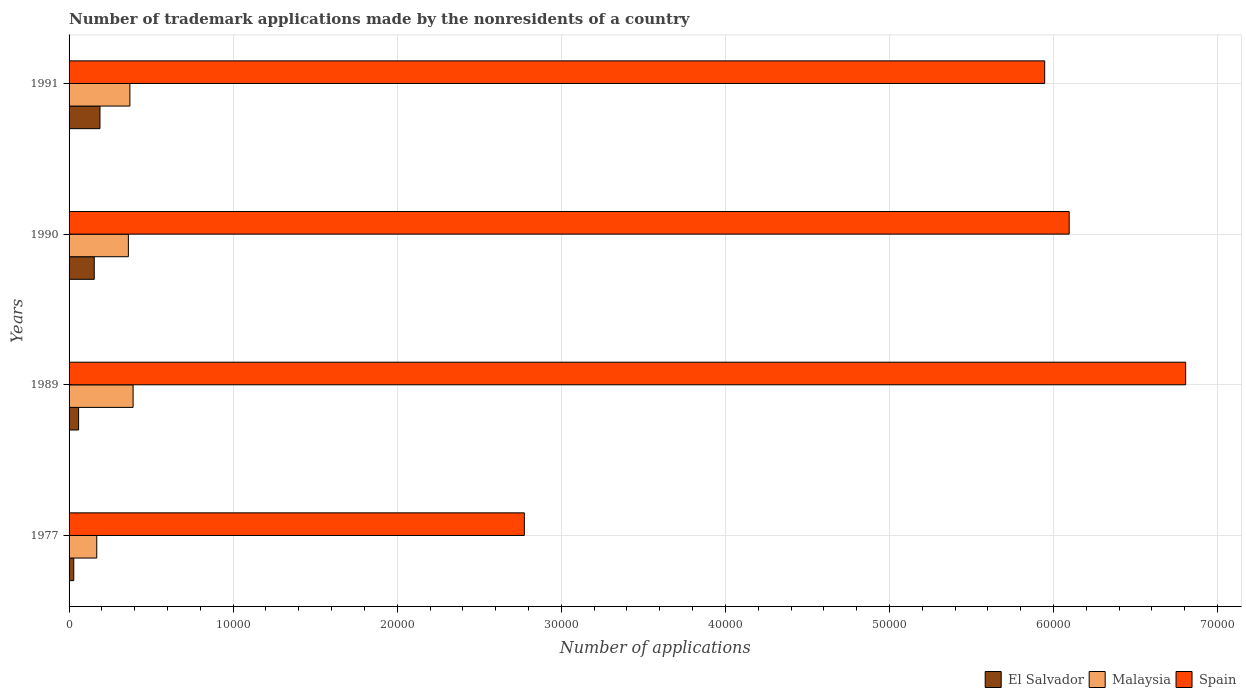Are the number of bars on each tick of the Y-axis equal?
Offer a terse response. Yes. How many bars are there on the 1st tick from the top?
Offer a very short reply. 3. How many bars are there on the 1st tick from the bottom?
Your response must be concise. 3. In how many cases, is the number of bars for a given year not equal to the number of legend labels?
Offer a very short reply. 0. What is the number of trademark applications made by the nonresidents in El Salvador in 1977?
Give a very brief answer. 287. Across all years, what is the maximum number of trademark applications made by the nonresidents in El Salvador?
Your answer should be compact. 1883. Across all years, what is the minimum number of trademark applications made by the nonresidents in Spain?
Keep it short and to the point. 2.77e+04. In which year was the number of trademark applications made by the nonresidents in Spain maximum?
Offer a very short reply. 1989. What is the total number of trademark applications made by the nonresidents in El Salvador in the graph?
Offer a very short reply. 4286. What is the difference between the number of trademark applications made by the nonresidents in Malaysia in 1977 and that in 1989?
Give a very brief answer. -2215. What is the difference between the number of trademark applications made by the nonresidents in Malaysia in 1990 and the number of trademark applications made by the nonresidents in El Salvador in 1991?
Provide a short and direct response. 1731. What is the average number of trademark applications made by the nonresidents in El Salvador per year?
Your response must be concise. 1071.5. In the year 1990, what is the difference between the number of trademark applications made by the nonresidents in Spain and number of trademark applications made by the nonresidents in Malaysia?
Ensure brevity in your answer.  5.73e+04. In how many years, is the number of trademark applications made by the nonresidents in El Salvador greater than 46000 ?
Your answer should be very brief. 0. What is the ratio of the number of trademark applications made by the nonresidents in Malaysia in 1977 to that in 1991?
Provide a succinct answer. 0.46. Is the number of trademark applications made by the nonresidents in Malaysia in 1989 less than that in 1990?
Keep it short and to the point. No. Is the difference between the number of trademark applications made by the nonresidents in Spain in 1977 and 1989 greater than the difference between the number of trademark applications made by the nonresidents in Malaysia in 1977 and 1989?
Your response must be concise. No. What is the difference between the highest and the second highest number of trademark applications made by the nonresidents in Spain?
Your answer should be compact. 7100. What is the difference between the highest and the lowest number of trademark applications made by the nonresidents in Malaysia?
Keep it short and to the point. 2215. In how many years, is the number of trademark applications made by the nonresidents in El Salvador greater than the average number of trademark applications made by the nonresidents in El Salvador taken over all years?
Provide a succinct answer. 2. Is the sum of the number of trademark applications made by the nonresidents in El Salvador in 1990 and 1991 greater than the maximum number of trademark applications made by the nonresidents in Spain across all years?
Provide a succinct answer. No. What does the 1st bar from the bottom in 1990 represents?
Keep it short and to the point. El Salvador. How many bars are there?
Provide a succinct answer. 12. How many years are there in the graph?
Provide a succinct answer. 4. What is the difference between two consecutive major ticks on the X-axis?
Offer a terse response. 10000. Are the values on the major ticks of X-axis written in scientific E-notation?
Keep it short and to the point. No. Does the graph contain any zero values?
Make the answer very short. No. Does the graph contain grids?
Make the answer very short. Yes. Where does the legend appear in the graph?
Offer a very short reply. Bottom right. What is the title of the graph?
Provide a succinct answer. Number of trademark applications made by the nonresidents of a country. Does "Kosovo" appear as one of the legend labels in the graph?
Your answer should be very brief. No. What is the label or title of the X-axis?
Your answer should be compact. Number of applications. What is the Number of applications in El Salvador in 1977?
Offer a terse response. 287. What is the Number of applications in Malaysia in 1977?
Offer a terse response. 1687. What is the Number of applications in Spain in 1977?
Your answer should be compact. 2.77e+04. What is the Number of applications in El Salvador in 1989?
Offer a terse response. 581. What is the Number of applications of Malaysia in 1989?
Ensure brevity in your answer.  3902. What is the Number of applications of Spain in 1989?
Your answer should be compact. 6.81e+04. What is the Number of applications of El Salvador in 1990?
Give a very brief answer. 1535. What is the Number of applications of Malaysia in 1990?
Give a very brief answer. 3614. What is the Number of applications in Spain in 1990?
Your answer should be very brief. 6.10e+04. What is the Number of applications in El Salvador in 1991?
Ensure brevity in your answer.  1883. What is the Number of applications in Malaysia in 1991?
Your answer should be very brief. 3707. What is the Number of applications of Spain in 1991?
Provide a succinct answer. 5.95e+04. Across all years, what is the maximum Number of applications in El Salvador?
Offer a very short reply. 1883. Across all years, what is the maximum Number of applications of Malaysia?
Your answer should be compact. 3902. Across all years, what is the maximum Number of applications in Spain?
Offer a very short reply. 6.81e+04. Across all years, what is the minimum Number of applications of El Salvador?
Ensure brevity in your answer.  287. Across all years, what is the minimum Number of applications of Malaysia?
Your answer should be compact. 1687. Across all years, what is the minimum Number of applications of Spain?
Give a very brief answer. 2.77e+04. What is the total Number of applications in El Salvador in the graph?
Offer a terse response. 4286. What is the total Number of applications of Malaysia in the graph?
Provide a succinct answer. 1.29e+04. What is the total Number of applications of Spain in the graph?
Give a very brief answer. 2.16e+05. What is the difference between the Number of applications of El Salvador in 1977 and that in 1989?
Your response must be concise. -294. What is the difference between the Number of applications in Malaysia in 1977 and that in 1989?
Your answer should be very brief. -2215. What is the difference between the Number of applications of Spain in 1977 and that in 1989?
Make the answer very short. -4.03e+04. What is the difference between the Number of applications in El Salvador in 1977 and that in 1990?
Keep it short and to the point. -1248. What is the difference between the Number of applications in Malaysia in 1977 and that in 1990?
Provide a succinct answer. -1927. What is the difference between the Number of applications in Spain in 1977 and that in 1990?
Your answer should be very brief. -3.32e+04. What is the difference between the Number of applications of El Salvador in 1977 and that in 1991?
Provide a short and direct response. -1596. What is the difference between the Number of applications in Malaysia in 1977 and that in 1991?
Ensure brevity in your answer.  -2020. What is the difference between the Number of applications of Spain in 1977 and that in 1991?
Offer a very short reply. -3.17e+04. What is the difference between the Number of applications in El Salvador in 1989 and that in 1990?
Make the answer very short. -954. What is the difference between the Number of applications of Malaysia in 1989 and that in 1990?
Provide a succinct answer. 288. What is the difference between the Number of applications in Spain in 1989 and that in 1990?
Keep it short and to the point. 7100. What is the difference between the Number of applications of El Salvador in 1989 and that in 1991?
Offer a terse response. -1302. What is the difference between the Number of applications in Malaysia in 1989 and that in 1991?
Provide a succinct answer. 195. What is the difference between the Number of applications in Spain in 1989 and that in 1991?
Keep it short and to the point. 8592. What is the difference between the Number of applications of El Salvador in 1990 and that in 1991?
Offer a terse response. -348. What is the difference between the Number of applications in Malaysia in 1990 and that in 1991?
Ensure brevity in your answer.  -93. What is the difference between the Number of applications in Spain in 1990 and that in 1991?
Make the answer very short. 1492. What is the difference between the Number of applications in El Salvador in 1977 and the Number of applications in Malaysia in 1989?
Offer a terse response. -3615. What is the difference between the Number of applications of El Salvador in 1977 and the Number of applications of Spain in 1989?
Offer a very short reply. -6.78e+04. What is the difference between the Number of applications in Malaysia in 1977 and the Number of applications in Spain in 1989?
Provide a short and direct response. -6.64e+04. What is the difference between the Number of applications in El Salvador in 1977 and the Number of applications in Malaysia in 1990?
Offer a terse response. -3327. What is the difference between the Number of applications of El Salvador in 1977 and the Number of applications of Spain in 1990?
Make the answer very short. -6.07e+04. What is the difference between the Number of applications of Malaysia in 1977 and the Number of applications of Spain in 1990?
Provide a short and direct response. -5.93e+04. What is the difference between the Number of applications of El Salvador in 1977 and the Number of applications of Malaysia in 1991?
Offer a very short reply. -3420. What is the difference between the Number of applications of El Salvador in 1977 and the Number of applications of Spain in 1991?
Your answer should be compact. -5.92e+04. What is the difference between the Number of applications of Malaysia in 1977 and the Number of applications of Spain in 1991?
Make the answer very short. -5.78e+04. What is the difference between the Number of applications of El Salvador in 1989 and the Number of applications of Malaysia in 1990?
Provide a short and direct response. -3033. What is the difference between the Number of applications in El Salvador in 1989 and the Number of applications in Spain in 1990?
Provide a short and direct response. -6.04e+04. What is the difference between the Number of applications of Malaysia in 1989 and the Number of applications of Spain in 1990?
Keep it short and to the point. -5.71e+04. What is the difference between the Number of applications in El Salvador in 1989 and the Number of applications in Malaysia in 1991?
Your answer should be compact. -3126. What is the difference between the Number of applications of El Salvador in 1989 and the Number of applications of Spain in 1991?
Your answer should be compact. -5.89e+04. What is the difference between the Number of applications of Malaysia in 1989 and the Number of applications of Spain in 1991?
Your answer should be very brief. -5.56e+04. What is the difference between the Number of applications of El Salvador in 1990 and the Number of applications of Malaysia in 1991?
Make the answer very short. -2172. What is the difference between the Number of applications in El Salvador in 1990 and the Number of applications in Spain in 1991?
Your answer should be very brief. -5.79e+04. What is the difference between the Number of applications in Malaysia in 1990 and the Number of applications in Spain in 1991?
Your answer should be very brief. -5.58e+04. What is the average Number of applications in El Salvador per year?
Ensure brevity in your answer.  1071.5. What is the average Number of applications in Malaysia per year?
Ensure brevity in your answer.  3227.5. What is the average Number of applications of Spain per year?
Your response must be concise. 5.41e+04. In the year 1977, what is the difference between the Number of applications in El Salvador and Number of applications in Malaysia?
Offer a terse response. -1400. In the year 1977, what is the difference between the Number of applications in El Salvador and Number of applications in Spain?
Make the answer very short. -2.75e+04. In the year 1977, what is the difference between the Number of applications of Malaysia and Number of applications of Spain?
Your answer should be compact. -2.61e+04. In the year 1989, what is the difference between the Number of applications of El Salvador and Number of applications of Malaysia?
Make the answer very short. -3321. In the year 1989, what is the difference between the Number of applications of El Salvador and Number of applications of Spain?
Make the answer very short. -6.75e+04. In the year 1989, what is the difference between the Number of applications in Malaysia and Number of applications in Spain?
Offer a terse response. -6.42e+04. In the year 1990, what is the difference between the Number of applications in El Salvador and Number of applications in Malaysia?
Give a very brief answer. -2079. In the year 1990, what is the difference between the Number of applications in El Salvador and Number of applications in Spain?
Your answer should be very brief. -5.94e+04. In the year 1990, what is the difference between the Number of applications of Malaysia and Number of applications of Spain?
Keep it short and to the point. -5.73e+04. In the year 1991, what is the difference between the Number of applications of El Salvador and Number of applications of Malaysia?
Give a very brief answer. -1824. In the year 1991, what is the difference between the Number of applications in El Salvador and Number of applications in Spain?
Your answer should be compact. -5.76e+04. In the year 1991, what is the difference between the Number of applications of Malaysia and Number of applications of Spain?
Offer a very short reply. -5.58e+04. What is the ratio of the Number of applications of El Salvador in 1977 to that in 1989?
Offer a very short reply. 0.49. What is the ratio of the Number of applications in Malaysia in 1977 to that in 1989?
Your answer should be very brief. 0.43. What is the ratio of the Number of applications of Spain in 1977 to that in 1989?
Provide a short and direct response. 0.41. What is the ratio of the Number of applications of El Salvador in 1977 to that in 1990?
Provide a succinct answer. 0.19. What is the ratio of the Number of applications in Malaysia in 1977 to that in 1990?
Your response must be concise. 0.47. What is the ratio of the Number of applications of Spain in 1977 to that in 1990?
Ensure brevity in your answer.  0.46. What is the ratio of the Number of applications in El Salvador in 1977 to that in 1991?
Ensure brevity in your answer.  0.15. What is the ratio of the Number of applications of Malaysia in 1977 to that in 1991?
Your response must be concise. 0.46. What is the ratio of the Number of applications in Spain in 1977 to that in 1991?
Your answer should be very brief. 0.47. What is the ratio of the Number of applications in El Salvador in 1989 to that in 1990?
Provide a succinct answer. 0.38. What is the ratio of the Number of applications of Malaysia in 1989 to that in 1990?
Your answer should be compact. 1.08. What is the ratio of the Number of applications of Spain in 1989 to that in 1990?
Ensure brevity in your answer.  1.12. What is the ratio of the Number of applications in El Salvador in 1989 to that in 1991?
Ensure brevity in your answer.  0.31. What is the ratio of the Number of applications of Malaysia in 1989 to that in 1991?
Ensure brevity in your answer.  1.05. What is the ratio of the Number of applications in Spain in 1989 to that in 1991?
Your answer should be compact. 1.14. What is the ratio of the Number of applications in El Salvador in 1990 to that in 1991?
Give a very brief answer. 0.82. What is the ratio of the Number of applications of Malaysia in 1990 to that in 1991?
Make the answer very short. 0.97. What is the ratio of the Number of applications of Spain in 1990 to that in 1991?
Keep it short and to the point. 1.03. What is the difference between the highest and the second highest Number of applications in El Salvador?
Offer a terse response. 348. What is the difference between the highest and the second highest Number of applications of Malaysia?
Make the answer very short. 195. What is the difference between the highest and the second highest Number of applications in Spain?
Offer a terse response. 7100. What is the difference between the highest and the lowest Number of applications in El Salvador?
Make the answer very short. 1596. What is the difference between the highest and the lowest Number of applications in Malaysia?
Provide a succinct answer. 2215. What is the difference between the highest and the lowest Number of applications in Spain?
Provide a short and direct response. 4.03e+04. 